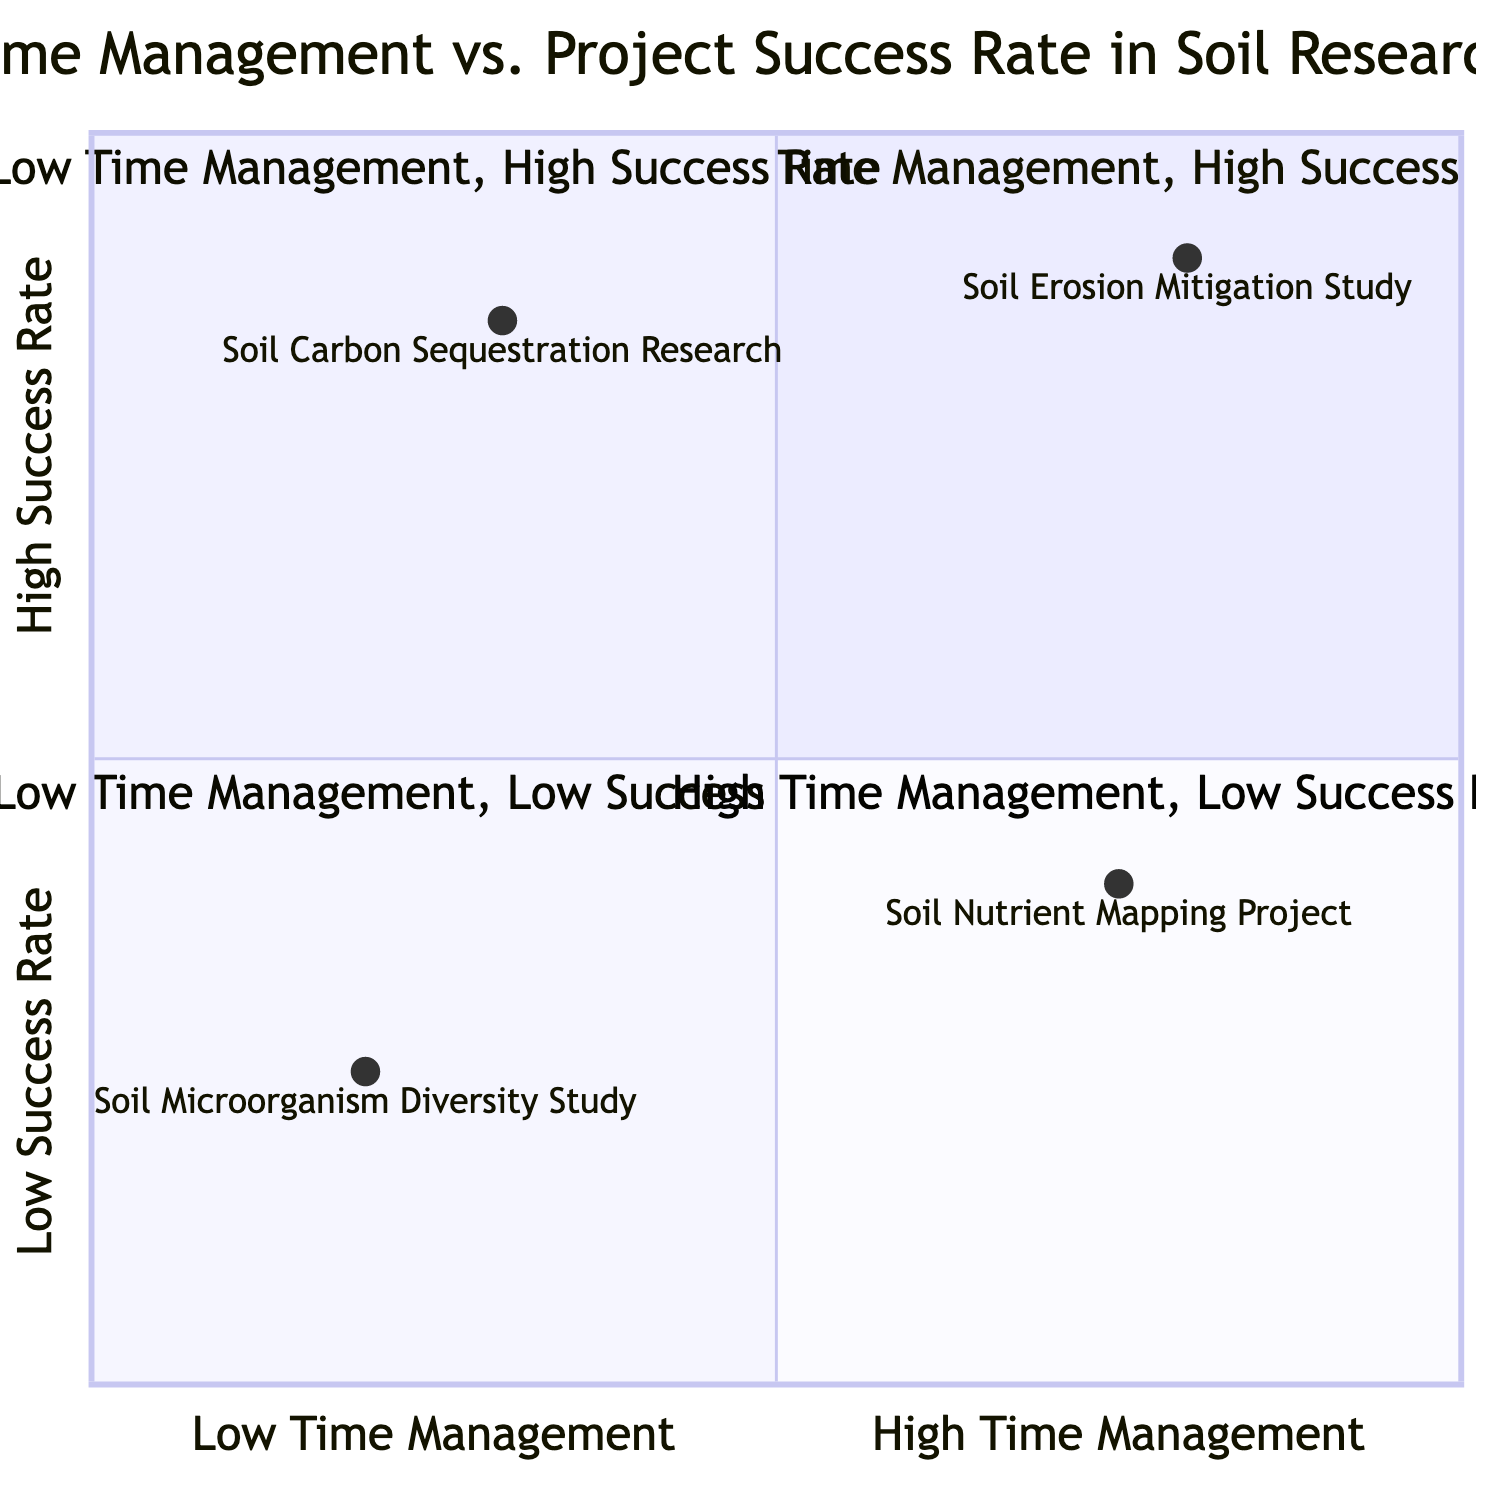What project is in the "High Time Management, High Success Rate" quadrant? The "High Time Management, High Success Rate" quadrant includes one project: the Soil Erosion Mitigation Study. This was identified directly from the quadrant's example listing.
Answer: Soil Erosion Mitigation Study How many projects are in the "Low Time Management, Low Success Rate" quadrant? The "Low Time Management, Low Success Rate" quadrant contains one project, the Soil Microorganism Diversity Study, as indicated by the example listing in that quadrant.
Answer: 1 What is the success rate of the Soil Nutrient Mapping Project? The Soil Nutrient Mapping Project is located in the "High Time Management, Low Success Rate" quadrant and has a success rate of 0.4, as shown by its coordinates on the chart.
Answer: 0.4 Which project has the highest success rate? Among all projects, the Soil Carbon Sequestration Research has the highest success rate at 0.85, found in the "Low Time Management, High Success Rate" quadrant. This value was clearly labeled next to the project’s coordinates.
Answer: Soil Carbon Sequestration Research What are the time management strategies used in the Soil Microorganism Diversity Study? The Soil Microorganism Diversity Study, located in the "Low Time Management, Low Success Rate" quadrant, employs time management strategies such as Irregular Schedules and Inconsistent Monitoring, as mentioned in its example description.
Answer: Irregular Schedules, Inconsistent Monitoring Which quadrant contains projects with the highest team expertise? The "High Time Management, High Success Rate" quadrant contains projects with high team expertise, as all projects listed there exhibit high expertise levels. This is determined by evaluating the expertise level descriptions in each quadrant.
Answer: High Time Management, High Success Rate What is the time management rating for the Soil Erosion Mitigation Study? The Soil Erosion Mitigation Study, situated in the "High Time Management, High Success Rate" quadrant, has a time management rating of 0.8, which is indicated in the diagram coordinates for that project.
Answer: 0.8 Which project utilized "Flexible Deadlines" as a time management strategy? The Soil Carbon Sequestration Research project is listed in the "Low Time Management, High Success Rate" quadrant and employs Flexible Deadlines as one of its time management strategies, as described in the examples provided.
Answer: Soil Carbon Sequestration Research 